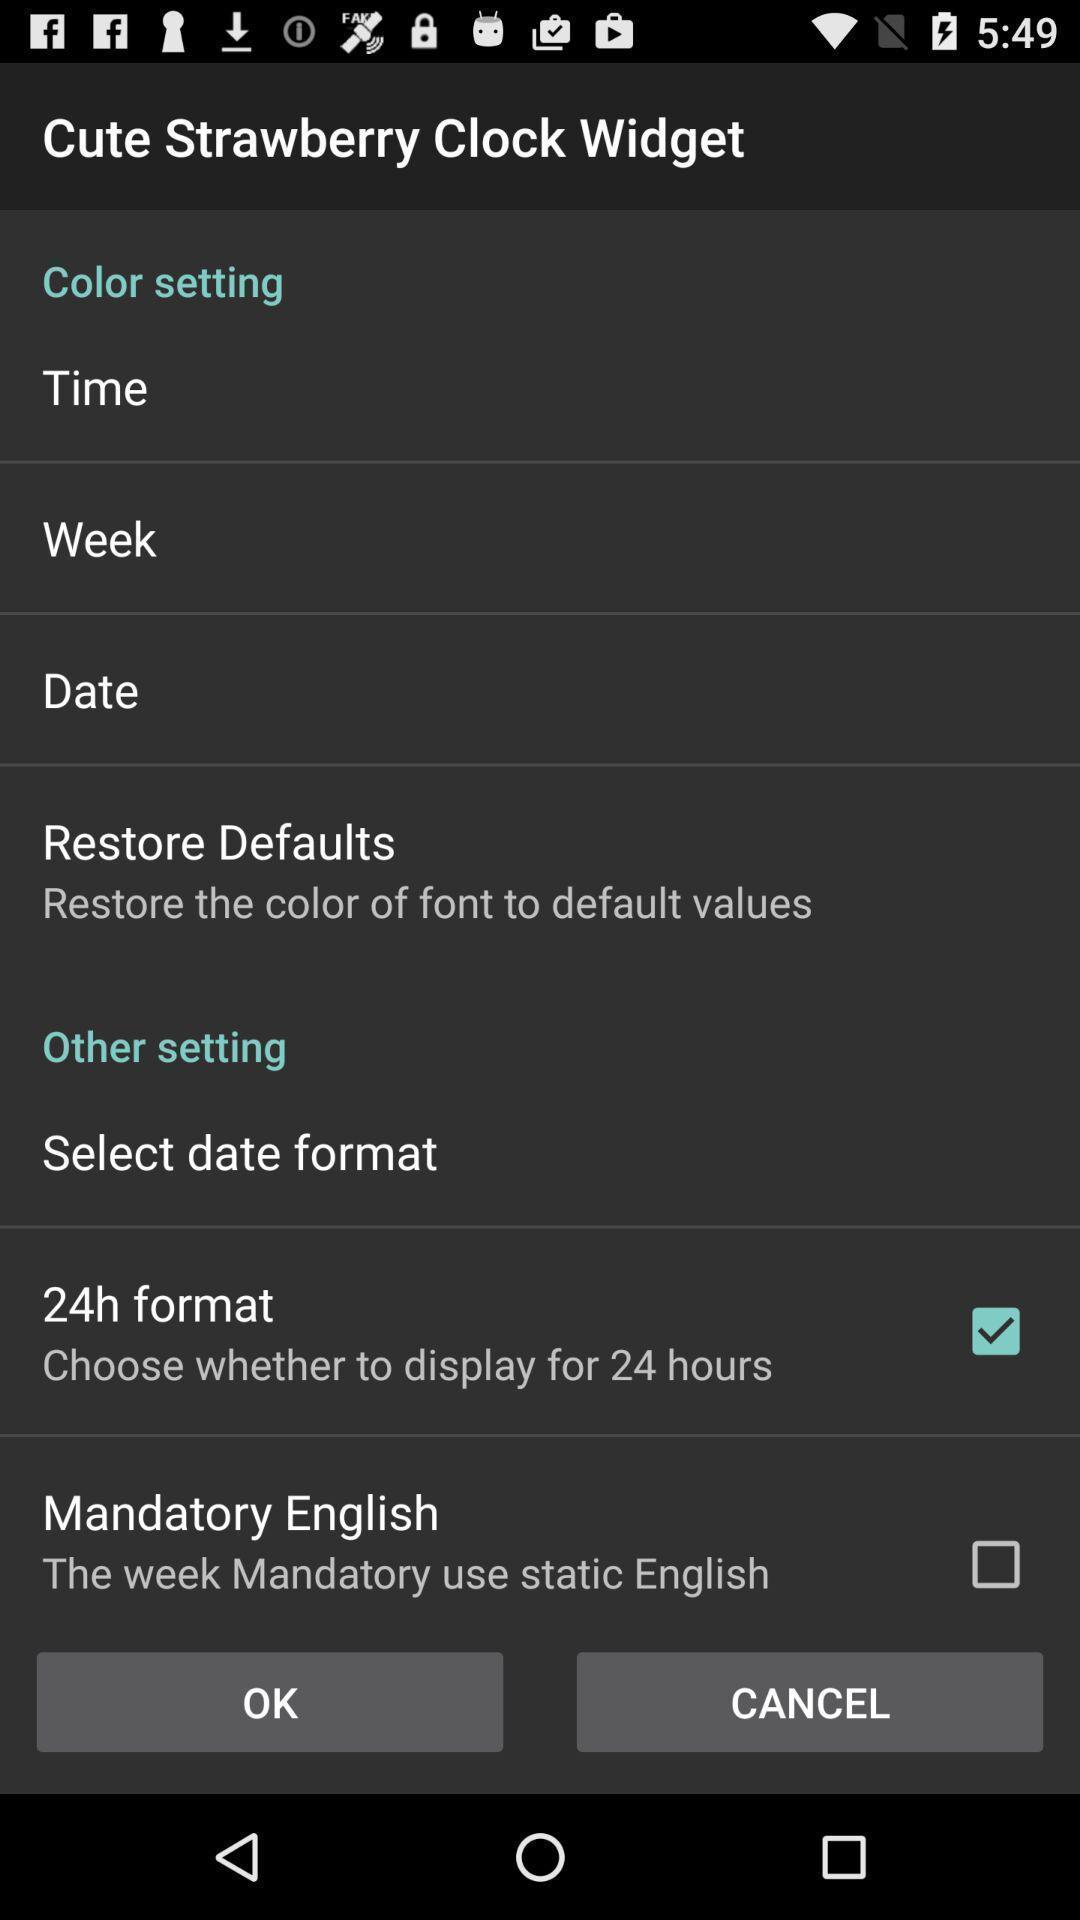Give me a narrative description of this picture. Screen showing settings page. 